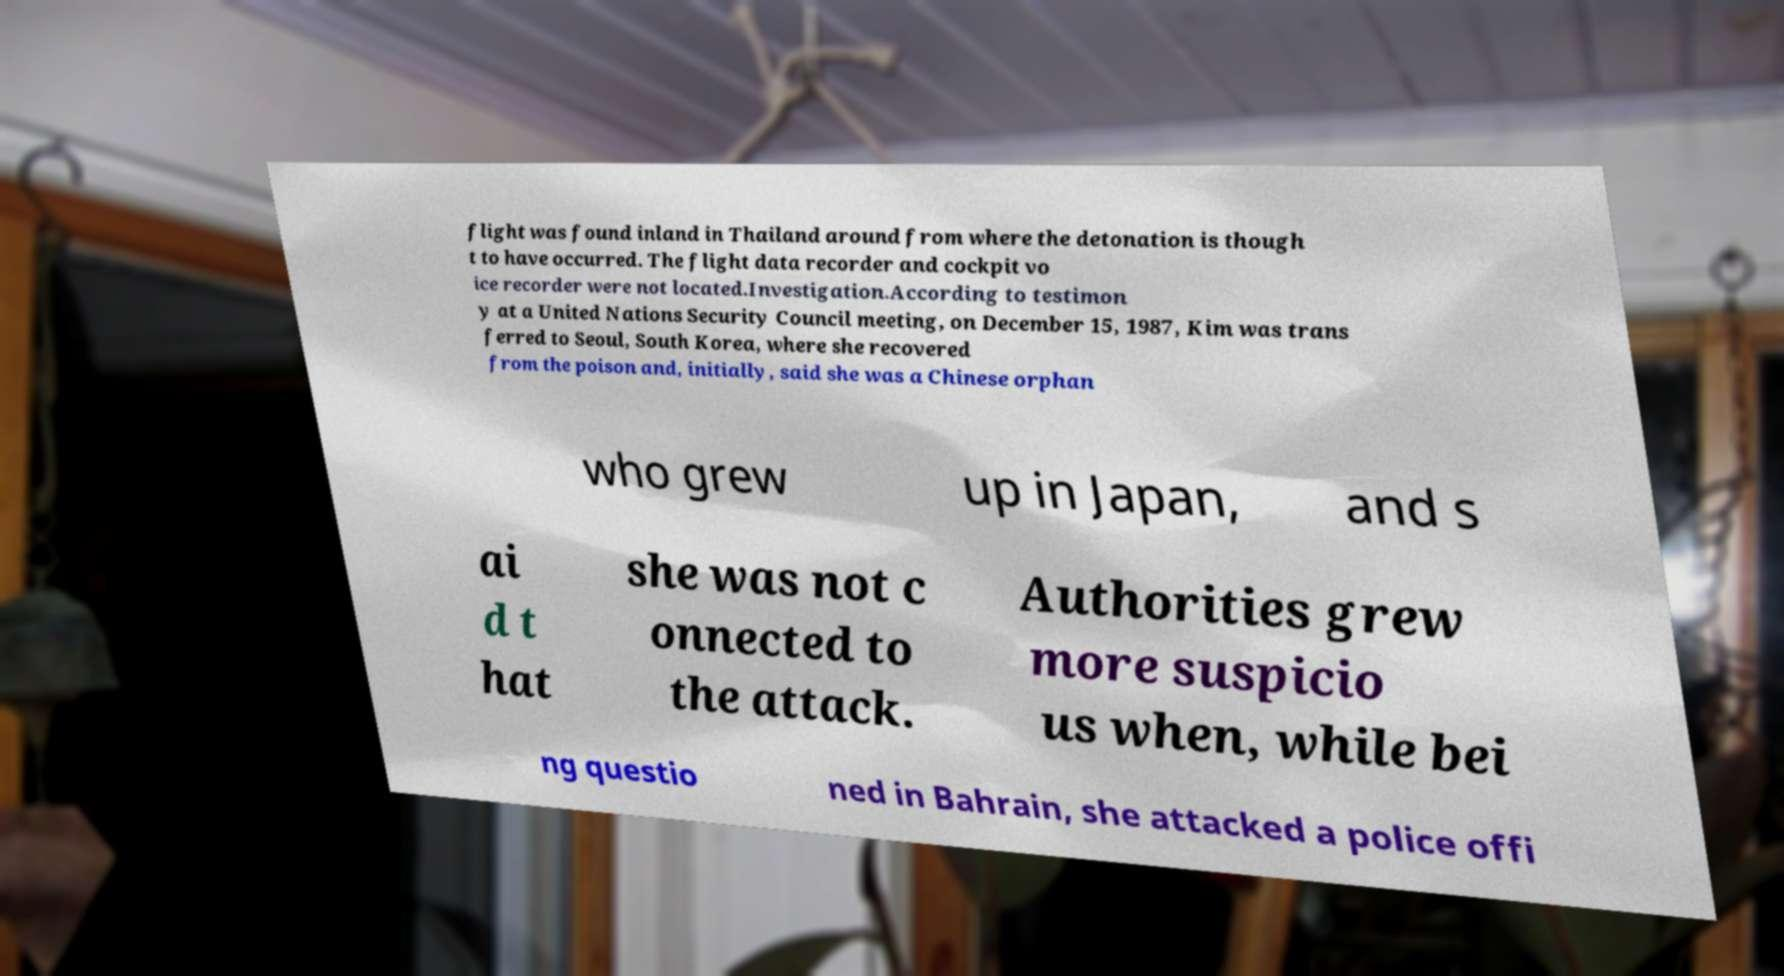I need the written content from this picture converted into text. Can you do that? flight was found inland in Thailand around from where the detonation is though t to have occurred. The flight data recorder and cockpit vo ice recorder were not located.Investigation.According to testimon y at a United Nations Security Council meeting, on December 15, 1987, Kim was trans ferred to Seoul, South Korea, where she recovered from the poison and, initially, said she was a Chinese orphan who grew up in Japan, and s ai d t hat she was not c onnected to the attack. Authorities grew more suspicio us when, while bei ng questio ned in Bahrain, she attacked a police offi 